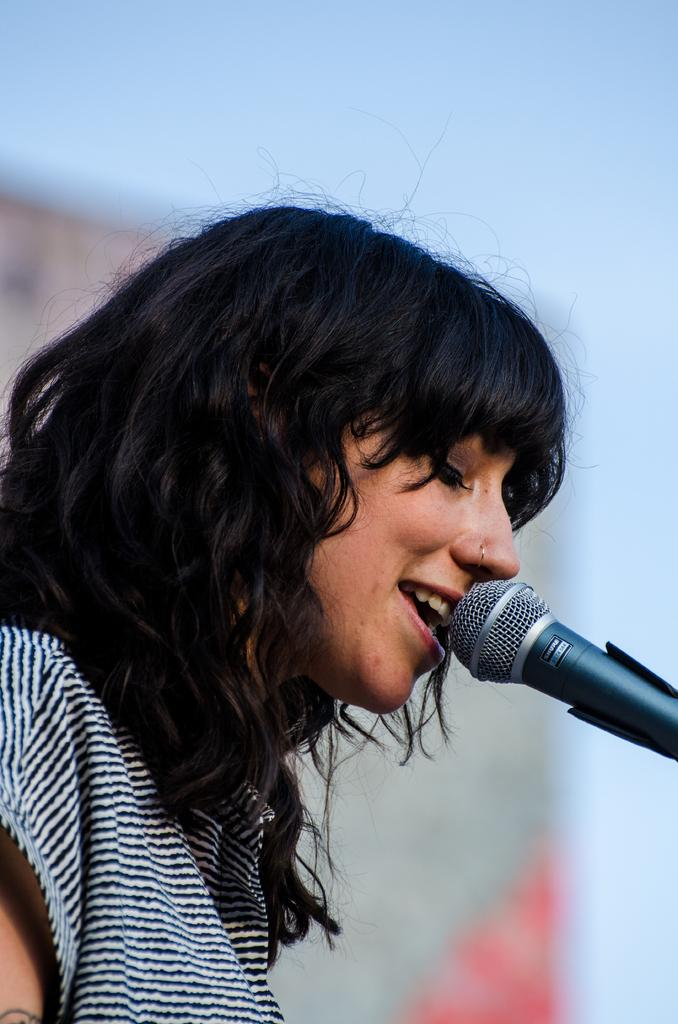What is the main subject of the picture? The main subject of the picture is a woman. What is the woman wearing in the image? The woman is wearing a shirt in the image. What activity is the woman engaged in? The woman is singing on a microphone in the image. What can be seen in the background of the image? There is a banner in the background of the image. What is visible above the woman in the image? The sky is visible in the image. What type of growth can be seen on the microphone in the image? There is no growth visible on the microphone in the image. How does the acoustics of the room affect the woman's singing in the image? The provided facts do not give any information about the acoustics of the room, so it cannot be determined how they affect the woman's singing. 